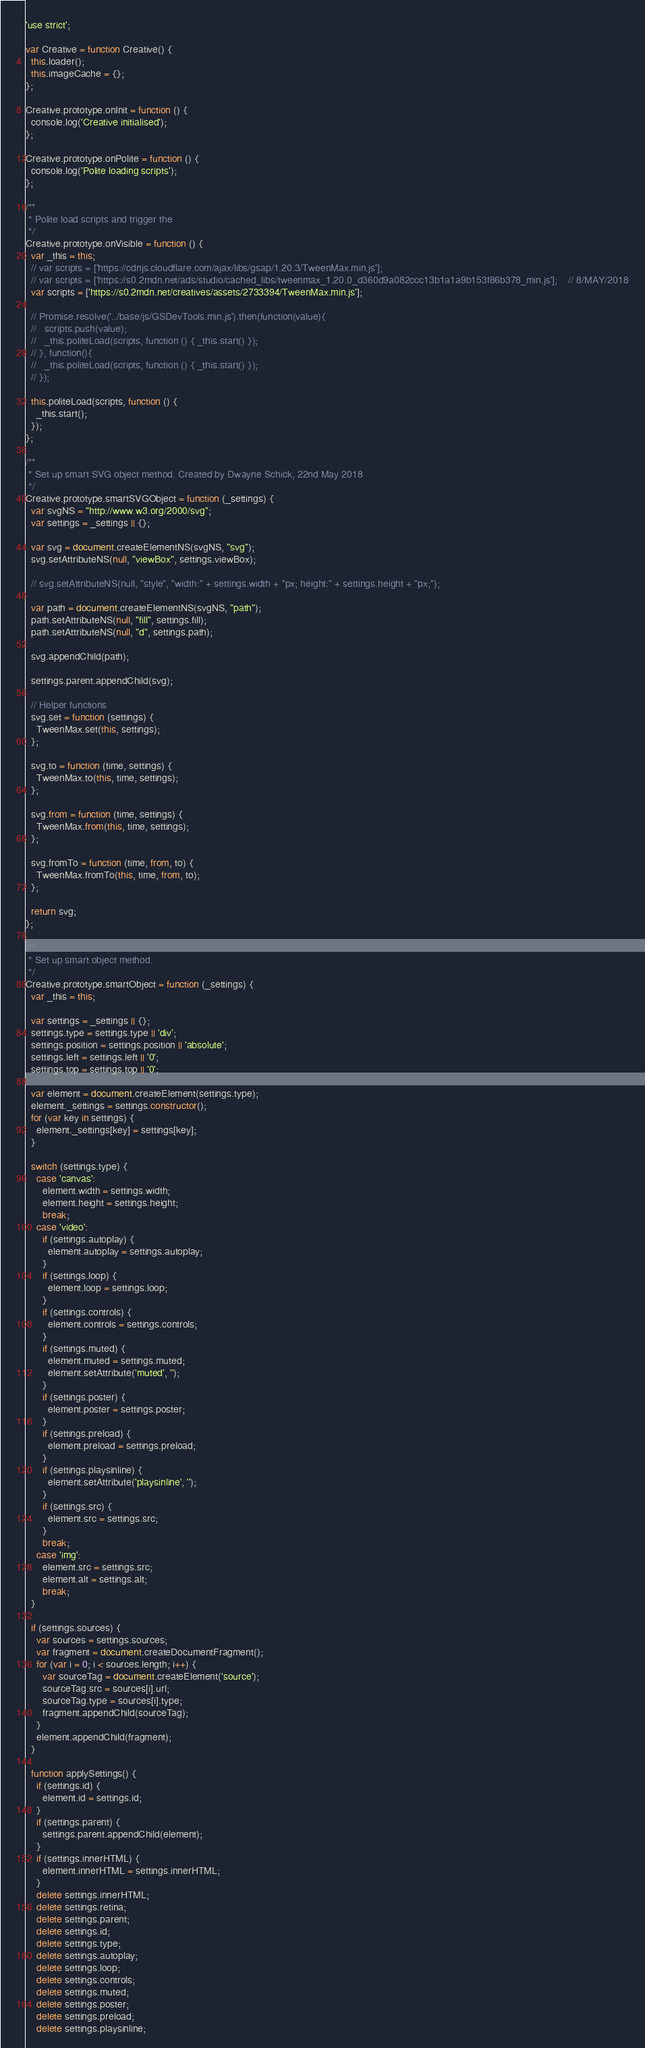Convert code to text. <code><loc_0><loc_0><loc_500><loc_500><_JavaScript_>'use strict';

var Creative = function Creative() {
  this.loader();
  this.imageCache = {};
};

Creative.prototype.onInit = function () {
  console.log('Creative initialised');
};

Creative.prototype.onPolite = function () {
  console.log('Polite loading scripts');
};

/**
 * Polite load scripts and trigger the
 */
Creative.prototype.onVisible = function () {
  var _this = this;
  // var scripts = ['https://cdnjs.cloudflare.com/ajax/libs/gsap/1.20.3/TweenMax.min.js'];
  // var scripts = ['https://s0.2mdn.net/ads/studio/cached_libs/tweenmax_1.20.0_d360d9a082ccc13b1a1a9b153f86b378_min.js'];    // 8/MAY/2018
  var scripts = ['https://s0.2mdn.net/creatives/assets/2733394/TweenMax.min.js'];

  // Promise.resolve('../base/js/GSDevTools.min.js').then(function(value){
  //   scripts.push(value);
  //   _this.politeLoad(scripts, function () { _this.start() });
  // }, function(){
  //   _this.politeLoad(scripts, function () { _this.start() });
  // });

  this.politeLoad(scripts, function () {
    _this.start();
  });
};

/**
 * Set up smart SVG object method. Created by Dwayne Schick, 22nd May 2018
 */
Creative.prototype.smartSVGObject = function (_settings) {
  var svgNS = "http://www.w3.org/2000/svg";
  var settings = _settings || {};

  var svg = document.createElementNS(svgNS, "svg");
  svg.setAttributeNS(null, "viewBox", settings.viewBox);

  // svg.setAttributeNS(null, "style", "width:" + settings.width + "px; height:" + settings.height + "px;");

  var path = document.createElementNS(svgNS, "path");
  path.setAttributeNS(null, "fill", settings.fill);
  path.setAttributeNS(null, "d", settings.path);

  svg.appendChild(path);

  settings.parent.appendChild(svg);

  // Helper functions
  svg.set = function (settings) {
    TweenMax.set(this, settings);
  };

  svg.to = function (time, settings) {
    TweenMax.to(this, time, settings);
  };

  svg.from = function (time, settings) {
    TweenMax.from(this, time, settings);
  };

  svg.fromTo = function (time, from, to) {
    TweenMax.fromTo(this, time, from, to);
  };

  return svg;
};

/**
 * Set up smart object method.
 */
Creative.prototype.smartObject = function (_settings) {
  var _this = this;

  var settings = _settings || {};
  settings.type = settings.type || 'div';
  settings.position = settings.position || 'absolute';
  settings.left = settings.left || '0';
  settings.top = settings.top || '0';

  var element = document.createElement(settings.type);
  element._settings = settings.constructor();
  for (var key in settings) {
    element._settings[key] = settings[key];
  }

  switch (settings.type) {
    case 'canvas':
      element.width = settings.width;
      element.height = settings.height;
      break;
    case 'video':
      if (settings.autoplay) {
        element.autoplay = settings.autoplay;
      }
      if (settings.loop) {
        element.loop = settings.loop;
      }
      if (settings.controls) {
        element.controls = settings.controls;
      }
      if (settings.muted) {
        element.muted = settings.muted;
        element.setAttribute('muted', '');
      }
      if (settings.poster) {
        element.poster = settings.poster;
      }
      if (settings.preload) {
        element.preload = settings.preload;
      }
      if (settings.playsinline) {
        element.setAttribute('playsinline', '');
      }
      if (settings.src) {
        element.src = settings.src;
      }
      break;
    case 'img':
      element.src = settings.src;
      element.alt = settings.alt;
      break;
  }

  if (settings.sources) {
    var sources = settings.sources;
    var fragment = document.createDocumentFragment();
    for (var i = 0; i < sources.length; i++) {
      var sourceTag = document.createElement('source');
      sourceTag.src = sources[i].url;
      sourceTag.type = sources[i].type;
      fragment.appendChild(sourceTag);
    }
    element.appendChild(fragment);
  }

  function applySettings() {
    if (settings.id) {
      element.id = settings.id;
    }
    if (settings.parent) {
      settings.parent.appendChild(element);
    }
    if (settings.innerHTML) {
      element.innerHTML = settings.innerHTML;
    }
    delete settings.innerHTML;
    delete settings.retina;
    delete settings.parent;
    delete settings.id;
    delete settings.type;
    delete settings.autoplay;
    delete settings.loop;
    delete settings.controls;
    delete settings.muted;
    delete settings.poster;
    delete settings.preload;
    delete settings.playsinline;</code> 